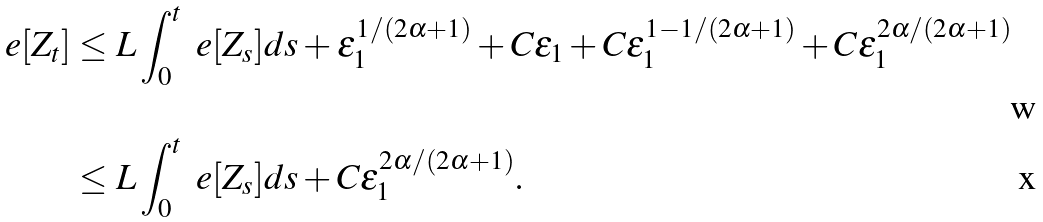<formula> <loc_0><loc_0><loc_500><loc_500>\ e [ Z _ { t } ] & \leq L \int _ { 0 } ^ { t } \ e [ Z _ { s } ] d s + \varepsilon _ { 1 } ^ { 1 / ( 2 \alpha + 1 ) } + C \varepsilon _ { 1 } + C \varepsilon _ { 1 } ^ { 1 - 1 / ( 2 \alpha + 1 ) } + C \varepsilon _ { 1 } ^ { 2 \alpha / ( 2 \alpha + 1 ) } \\ & \leq L \int _ { 0 } ^ { t } \ e [ Z _ { s } ] d s + C \varepsilon _ { 1 } ^ { 2 \alpha / ( 2 \alpha + 1 ) } .</formula> 